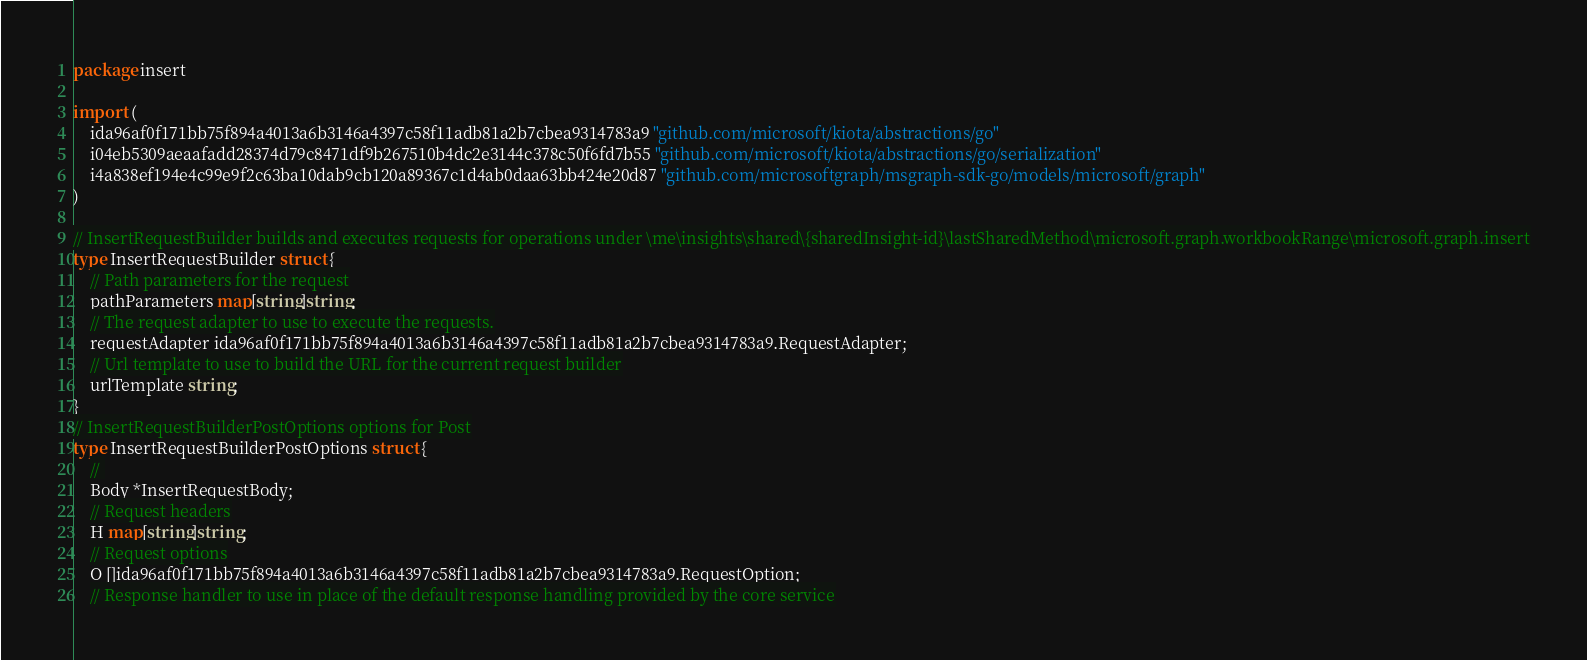<code> <loc_0><loc_0><loc_500><loc_500><_Go_>package insert

import (
    ida96af0f171bb75f894a4013a6b3146a4397c58f11adb81a2b7cbea9314783a9 "github.com/microsoft/kiota/abstractions/go"
    i04eb5309aeaafadd28374d79c8471df9b267510b4dc2e3144c378c50f6fd7b55 "github.com/microsoft/kiota/abstractions/go/serialization"
    i4a838ef194e4c99e9f2c63ba10dab9cb120a89367c1d4ab0daa63bb424e20d87 "github.com/microsoftgraph/msgraph-sdk-go/models/microsoft/graph"
)

// InsertRequestBuilder builds and executes requests for operations under \me\insights\shared\{sharedInsight-id}\lastSharedMethod\microsoft.graph.workbookRange\microsoft.graph.insert
type InsertRequestBuilder struct {
    // Path parameters for the request
    pathParameters map[string]string;
    // The request adapter to use to execute the requests.
    requestAdapter ida96af0f171bb75f894a4013a6b3146a4397c58f11adb81a2b7cbea9314783a9.RequestAdapter;
    // Url template to use to build the URL for the current request builder
    urlTemplate string;
}
// InsertRequestBuilderPostOptions options for Post
type InsertRequestBuilderPostOptions struct {
    // 
    Body *InsertRequestBody;
    // Request headers
    H map[string]string;
    // Request options
    O []ida96af0f171bb75f894a4013a6b3146a4397c58f11adb81a2b7cbea9314783a9.RequestOption;
    // Response handler to use in place of the default response handling provided by the core service</code> 